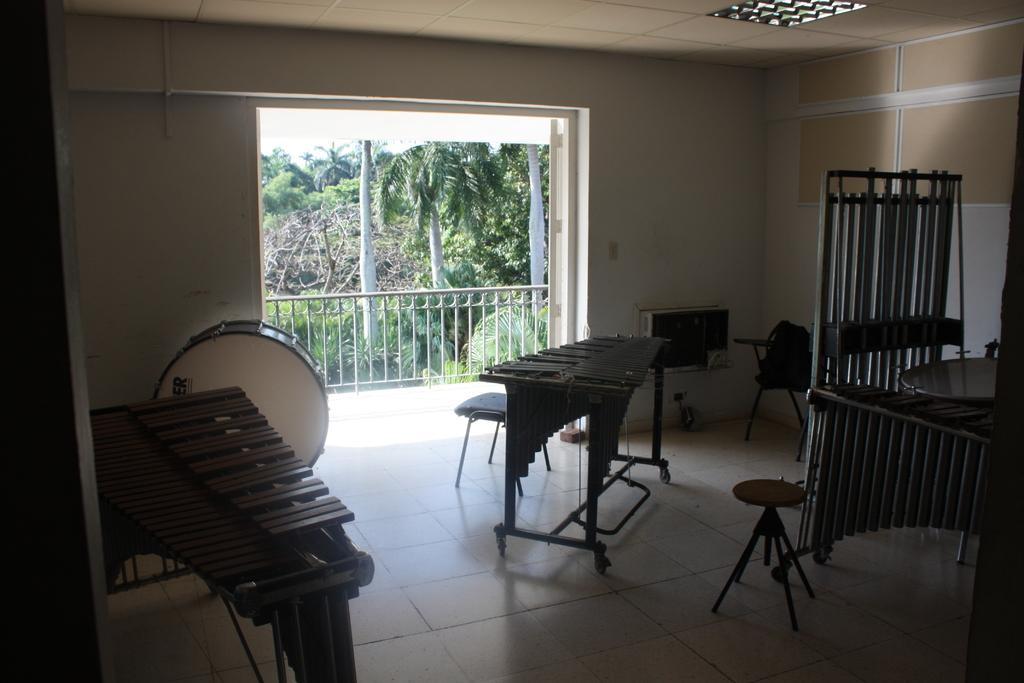What objects are present in the image that are used for making music? There are musical instruments in the image. What type of seating can be seen in the image? There are chairs and benches in the image. What can be seen in the background of the image? There is a door, fencing, and trees in the background of the image. What organization is responsible for the window in the image? There is no window present in the image, so it is not possible to determine which organization might be responsible for it. 